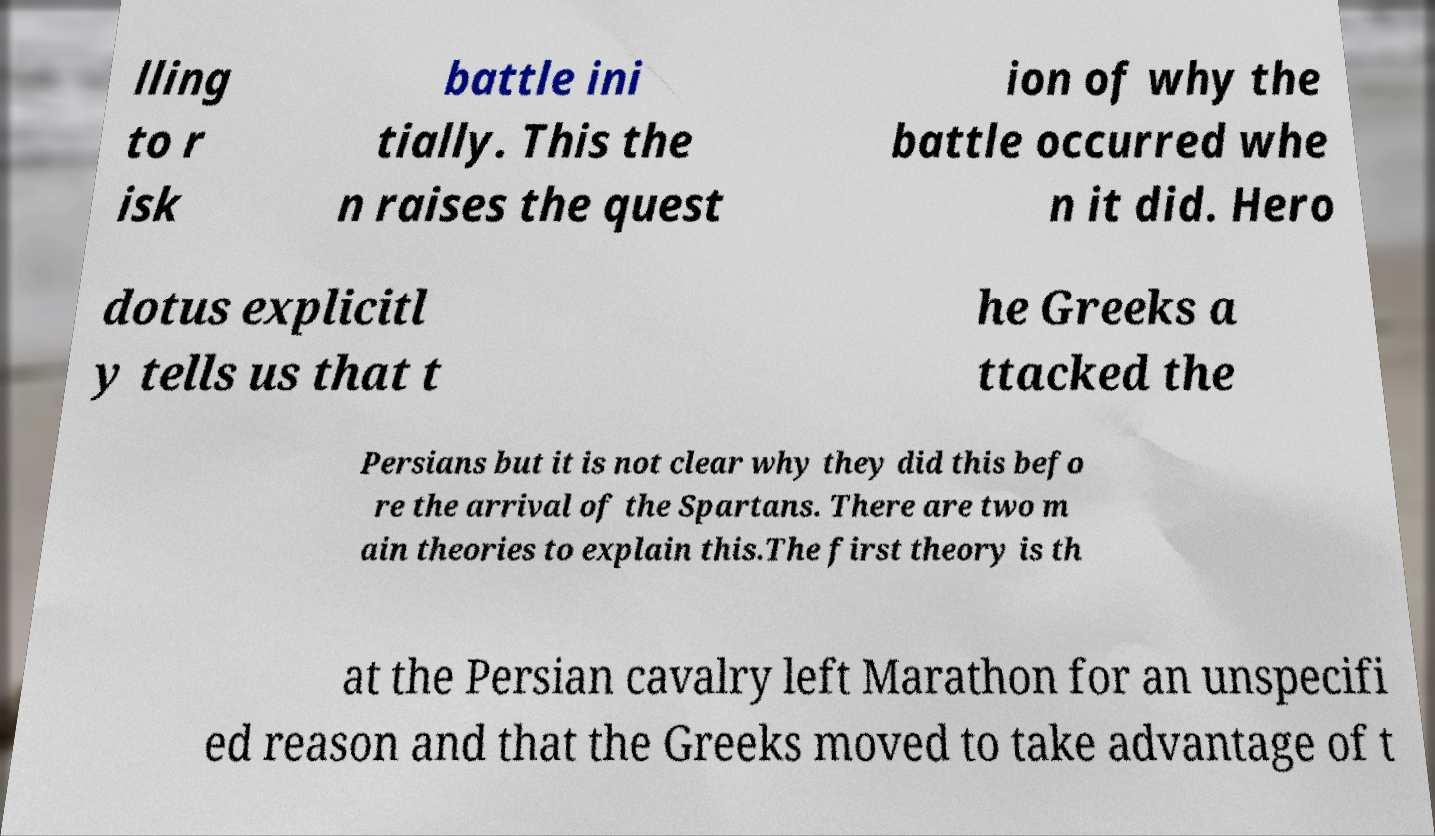Can you read and provide the text displayed in the image?This photo seems to have some interesting text. Can you extract and type it out for me? lling to r isk battle ini tially. This the n raises the quest ion of why the battle occurred whe n it did. Hero dotus explicitl y tells us that t he Greeks a ttacked the Persians but it is not clear why they did this befo re the arrival of the Spartans. There are two m ain theories to explain this.The first theory is th at the Persian cavalry left Marathon for an unspecifi ed reason and that the Greeks moved to take advantage of t 